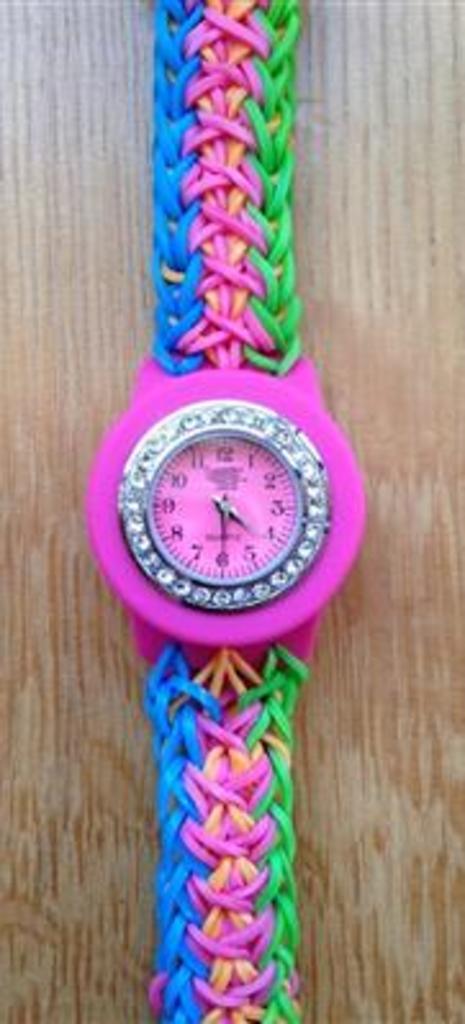Where is the minute hand pointed?
Keep it short and to the point. 6. What time is on the watch?
Ensure brevity in your answer.  4:30. 